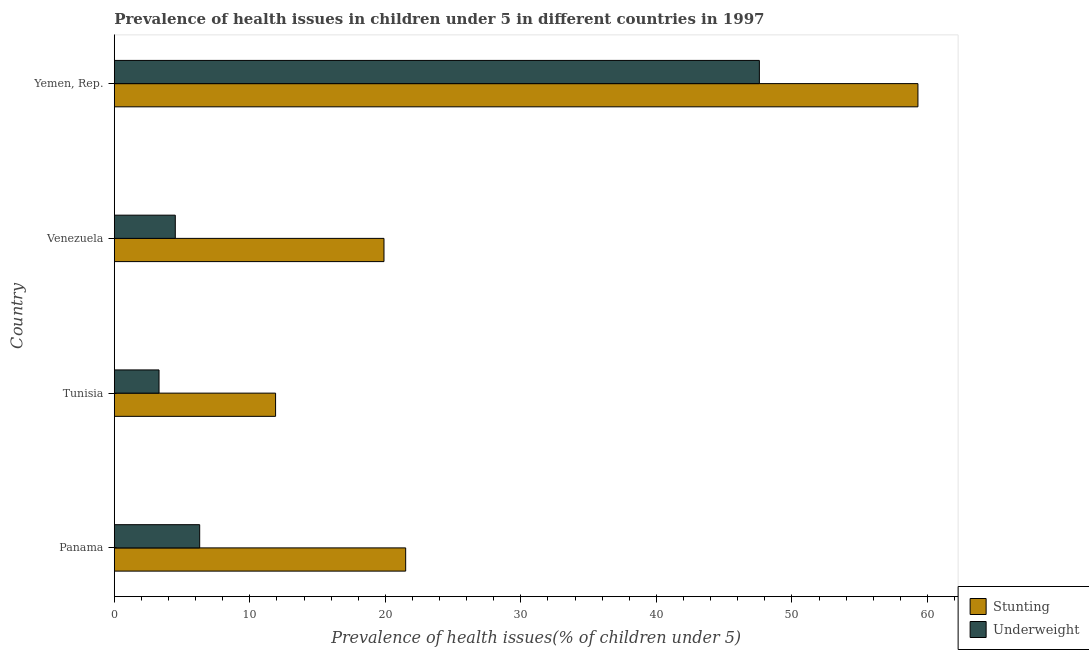How many groups of bars are there?
Give a very brief answer. 4. Are the number of bars per tick equal to the number of legend labels?
Your answer should be very brief. Yes. How many bars are there on the 2nd tick from the top?
Your response must be concise. 2. How many bars are there on the 2nd tick from the bottom?
Provide a succinct answer. 2. What is the label of the 2nd group of bars from the top?
Your response must be concise. Venezuela. In how many cases, is the number of bars for a given country not equal to the number of legend labels?
Provide a succinct answer. 0. What is the percentage of stunted children in Yemen, Rep.?
Offer a terse response. 59.3. Across all countries, what is the maximum percentage of underweight children?
Make the answer very short. 47.6. Across all countries, what is the minimum percentage of underweight children?
Provide a succinct answer. 3.3. In which country was the percentage of stunted children maximum?
Make the answer very short. Yemen, Rep. In which country was the percentage of underweight children minimum?
Keep it short and to the point. Tunisia. What is the total percentage of underweight children in the graph?
Keep it short and to the point. 61.7. What is the difference between the percentage of stunted children in Yemen, Rep. and the percentage of underweight children in Tunisia?
Give a very brief answer. 56. What is the average percentage of stunted children per country?
Keep it short and to the point. 28.15. What is the difference between the percentage of underweight children and percentage of stunted children in Panama?
Your answer should be very brief. -15.2. What is the ratio of the percentage of underweight children in Tunisia to that in Venezuela?
Ensure brevity in your answer.  0.73. Is the difference between the percentage of underweight children in Tunisia and Yemen, Rep. greater than the difference between the percentage of stunted children in Tunisia and Yemen, Rep.?
Give a very brief answer. Yes. What is the difference between the highest and the second highest percentage of underweight children?
Provide a succinct answer. 41.3. What is the difference between the highest and the lowest percentage of stunted children?
Provide a succinct answer. 47.4. In how many countries, is the percentage of underweight children greater than the average percentage of underweight children taken over all countries?
Provide a short and direct response. 1. What does the 1st bar from the top in Tunisia represents?
Offer a very short reply. Underweight. What does the 2nd bar from the bottom in Tunisia represents?
Offer a terse response. Underweight. Are all the bars in the graph horizontal?
Offer a terse response. Yes. How many countries are there in the graph?
Make the answer very short. 4. Does the graph contain any zero values?
Provide a succinct answer. No. Does the graph contain grids?
Your response must be concise. No. Where does the legend appear in the graph?
Offer a terse response. Bottom right. How are the legend labels stacked?
Provide a short and direct response. Vertical. What is the title of the graph?
Give a very brief answer. Prevalence of health issues in children under 5 in different countries in 1997. What is the label or title of the X-axis?
Give a very brief answer. Prevalence of health issues(% of children under 5). What is the Prevalence of health issues(% of children under 5) in Underweight in Panama?
Give a very brief answer. 6.3. What is the Prevalence of health issues(% of children under 5) in Stunting in Tunisia?
Your answer should be compact. 11.9. What is the Prevalence of health issues(% of children under 5) of Underweight in Tunisia?
Your answer should be compact. 3.3. What is the Prevalence of health issues(% of children under 5) in Stunting in Venezuela?
Give a very brief answer. 19.9. What is the Prevalence of health issues(% of children under 5) of Stunting in Yemen, Rep.?
Your response must be concise. 59.3. What is the Prevalence of health issues(% of children under 5) of Underweight in Yemen, Rep.?
Your answer should be very brief. 47.6. Across all countries, what is the maximum Prevalence of health issues(% of children under 5) of Stunting?
Your response must be concise. 59.3. Across all countries, what is the maximum Prevalence of health issues(% of children under 5) in Underweight?
Offer a very short reply. 47.6. Across all countries, what is the minimum Prevalence of health issues(% of children under 5) of Stunting?
Ensure brevity in your answer.  11.9. Across all countries, what is the minimum Prevalence of health issues(% of children under 5) of Underweight?
Your answer should be compact. 3.3. What is the total Prevalence of health issues(% of children under 5) in Stunting in the graph?
Your answer should be compact. 112.6. What is the total Prevalence of health issues(% of children under 5) in Underweight in the graph?
Offer a very short reply. 61.7. What is the difference between the Prevalence of health issues(% of children under 5) in Stunting in Panama and that in Tunisia?
Give a very brief answer. 9.6. What is the difference between the Prevalence of health issues(% of children under 5) of Underweight in Panama and that in Venezuela?
Your answer should be very brief. 1.8. What is the difference between the Prevalence of health issues(% of children under 5) of Stunting in Panama and that in Yemen, Rep.?
Provide a succinct answer. -37.8. What is the difference between the Prevalence of health issues(% of children under 5) in Underweight in Panama and that in Yemen, Rep.?
Your answer should be compact. -41.3. What is the difference between the Prevalence of health issues(% of children under 5) in Stunting in Tunisia and that in Yemen, Rep.?
Provide a succinct answer. -47.4. What is the difference between the Prevalence of health issues(% of children under 5) of Underweight in Tunisia and that in Yemen, Rep.?
Your response must be concise. -44.3. What is the difference between the Prevalence of health issues(% of children under 5) in Stunting in Venezuela and that in Yemen, Rep.?
Your answer should be compact. -39.4. What is the difference between the Prevalence of health issues(% of children under 5) in Underweight in Venezuela and that in Yemen, Rep.?
Your response must be concise. -43.1. What is the difference between the Prevalence of health issues(% of children under 5) in Stunting in Panama and the Prevalence of health issues(% of children under 5) in Underweight in Tunisia?
Ensure brevity in your answer.  18.2. What is the difference between the Prevalence of health issues(% of children under 5) in Stunting in Panama and the Prevalence of health issues(% of children under 5) in Underweight in Venezuela?
Make the answer very short. 17. What is the difference between the Prevalence of health issues(% of children under 5) of Stunting in Panama and the Prevalence of health issues(% of children under 5) of Underweight in Yemen, Rep.?
Give a very brief answer. -26.1. What is the difference between the Prevalence of health issues(% of children under 5) in Stunting in Tunisia and the Prevalence of health issues(% of children under 5) in Underweight in Venezuela?
Make the answer very short. 7.4. What is the difference between the Prevalence of health issues(% of children under 5) of Stunting in Tunisia and the Prevalence of health issues(% of children under 5) of Underweight in Yemen, Rep.?
Offer a terse response. -35.7. What is the difference between the Prevalence of health issues(% of children under 5) of Stunting in Venezuela and the Prevalence of health issues(% of children under 5) of Underweight in Yemen, Rep.?
Offer a terse response. -27.7. What is the average Prevalence of health issues(% of children under 5) of Stunting per country?
Provide a succinct answer. 28.15. What is the average Prevalence of health issues(% of children under 5) of Underweight per country?
Provide a succinct answer. 15.43. What is the difference between the Prevalence of health issues(% of children under 5) in Stunting and Prevalence of health issues(% of children under 5) in Underweight in Panama?
Offer a terse response. 15.2. What is the difference between the Prevalence of health issues(% of children under 5) in Stunting and Prevalence of health issues(% of children under 5) in Underweight in Venezuela?
Your answer should be compact. 15.4. What is the ratio of the Prevalence of health issues(% of children under 5) in Stunting in Panama to that in Tunisia?
Keep it short and to the point. 1.81. What is the ratio of the Prevalence of health issues(% of children under 5) in Underweight in Panama to that in Tunisia?
Make the answer very short. 1.91. What is the ratio of the Prevalence of health issues(% of children under 5) of Stunting in Panama to that in Venezuela?
Give a very brief answer. 1.08. What is the ratio of the Prevalence of health issues(% of children under 5) in Stunting in Panama to that in Yemen, Rep.?
Your response must be concise. 0.36. What is the ratio of the Prevalence of health issues(% of children under 5) in Underweight in Panama to that in Yemen, Rep.?
Provide a short and direct response. 0.13. What is the ratio of the Prevalence of health issues(% of children under 5) of Stunting in Tunisia to that in Venezuela?
Provide a short and direct response. 0.6. What is the ratio of the Prevalence of health issues(% of children under 5) in Underweight in Tunisia to that in Venezuela?
Make the answer very short. 0.73. What is the ratio of the Prevalence of health issues(% of children under 5) in Stunting in Tunisia to that in Yemen, Rep.?
Make the answer very short. 0.2. What is the ratio of the Prevalence of health issues(% of children under 5) in Underweight in Tunisia to that in Yemen, Rep.?
Provide a short and direct response. 0.07. What is the ratio of the Prevalence of health issues(% of children under 5) of Stunting in Venezuela to that in Yemen, Rep.?
Offer a very short reply. 0.34. What is the ratio of the Prevalence of health issues(% of children under 5) in Underweight in Venezuela to that in Yemen, Rep.?
Ensure brevity in your answer.  0.09. What is the difference between the highest and the second highest Prevalence of health issues(% of children under 5) in Stunting?
Provide a short and direct response. 37.8. What is the difference between the highest and the second highest Prevalence of health issues(% of children under 5) in Underweight?
Your answer should be very brief. 41.3. What is the difference between the highest and the lowest Prevalence of health issues(% of children under 5) in Stunting?
Offer a terse response. 47.4. What is the difference between the highest and the lowest Prevalence of health issues(% of children under 5) of Underweight?
Your answer should be very brief. 44.3. 